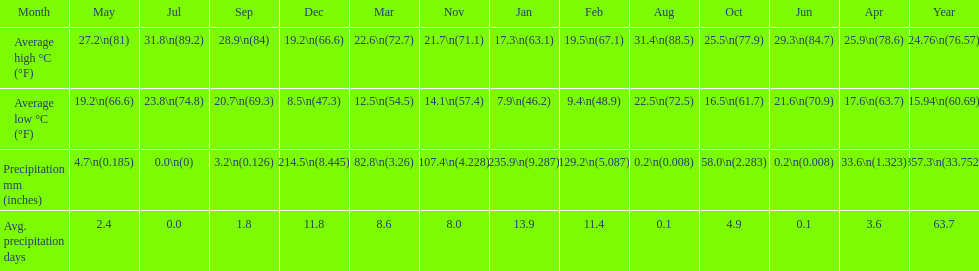Which month held the most precipitation? January. 